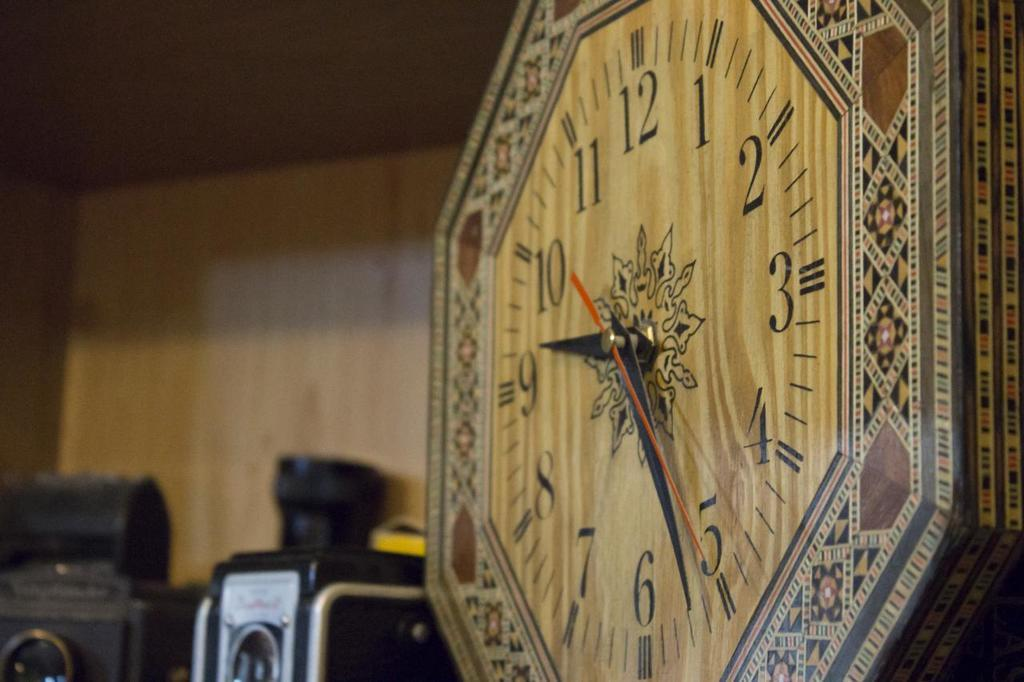<image>
Present a compact description of the photo's key features. Old clock that has the red hand on the number 5. 